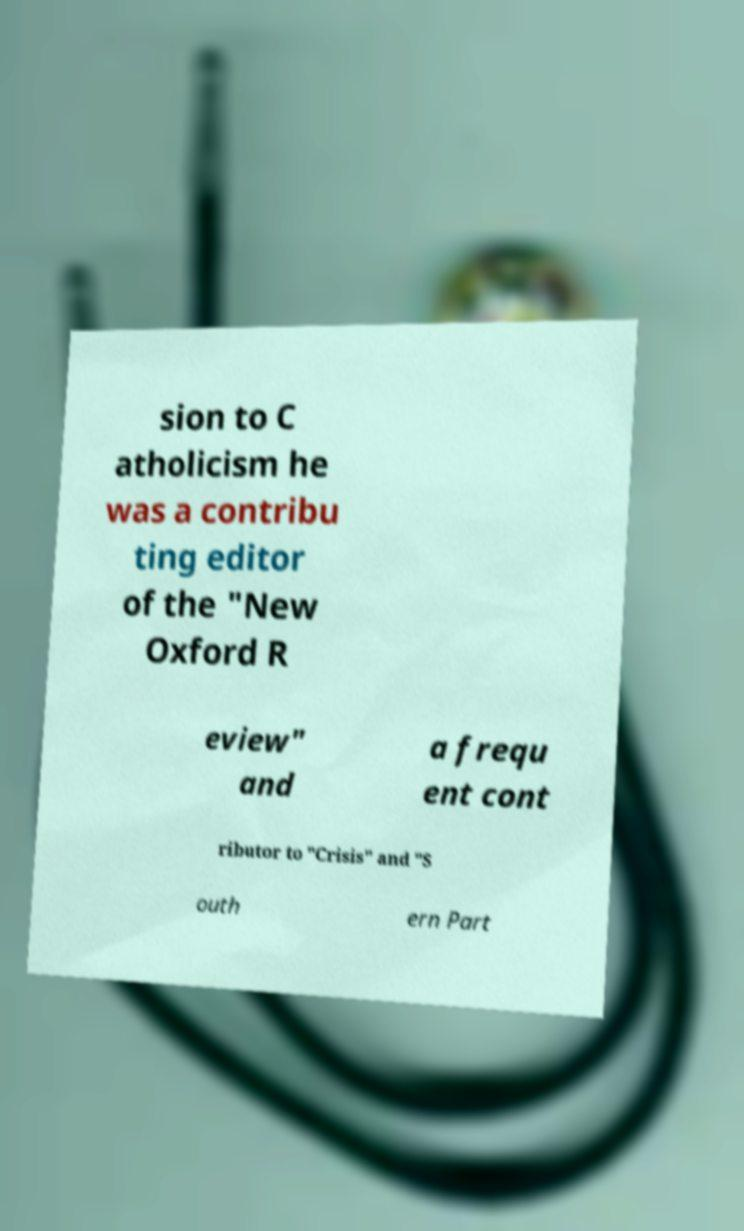I need the written content from this picture converted into text. Can you do that? sion to C atholicism he was a contribu ting editor of the "New Oxford R eview" and a frequ ent cont ributor to "Crisis" and "S outh ern Part 